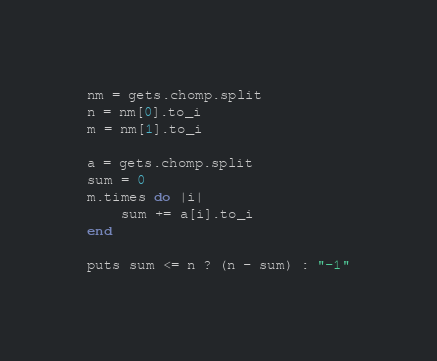Convert code to text. <code><loc_0><loc_0><loc_500><loc_500><_Ruby_>nm = gets.chomp.split
n = nm[0].to_i
m = nm[1].to_i

a = gets.chomp.split
sum = 0
m.times do |i|
    sum += a[i].to_i
end

puts sum <= n ? (n - sum) : "-1"</code> 